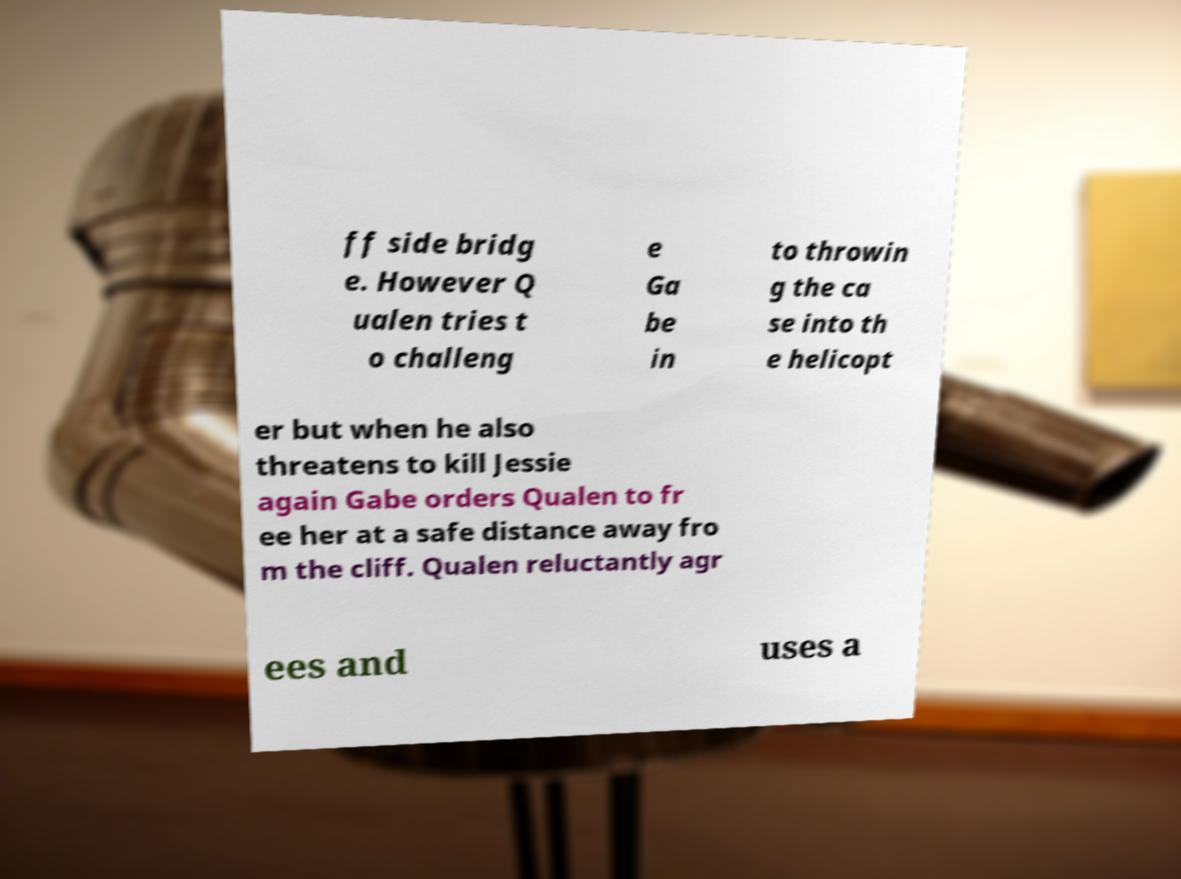Could you extract and type out the text from this image? ff side bridg e. However Q ualen tries t o challeng e Ga be in to throwin g the ca se into th e helicopt er but when he also threatens to kill Jessie again Gabe orders Qualen to fr ee her at a safe distance away fro m the cliff. Qualen reluctantly agr ees and uses a 